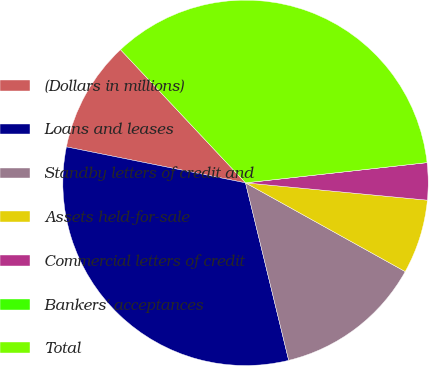Convert chart. <chart><loc_0><loc_0><loc_500><loc_500><pie_chart><fcel>(Dollars in millions)<fcel>Loans and leases<fcel>Standby letters of credit and<fcel>Assets held-for-sale<fcel>Commercial letters of credit<fcel>Bankers' acceptances<fcel>Total<nl><fcel>9.85%<fcel>31.95%<fcel>13.13%<fcel>6.56%<fcel>3.28%<fcel>0.0%<fcel>35.23%<nl></chart> 